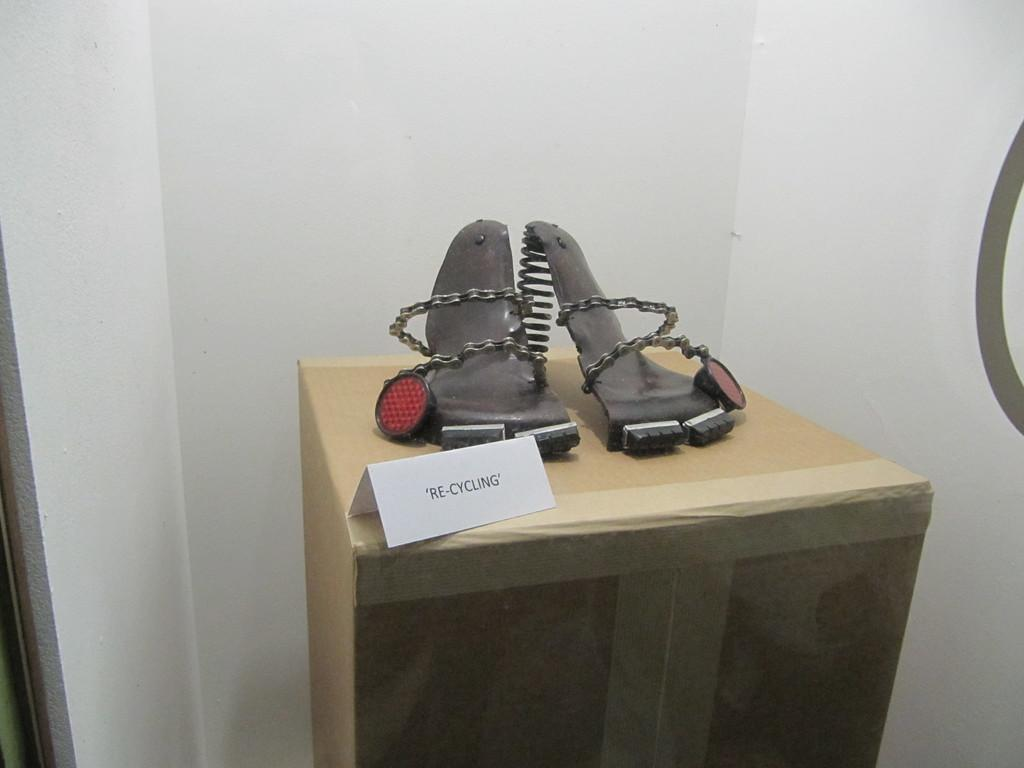What is the main subject of the image? There is a recycled object in the center of the image. How is the recycled object positioned in the image? The recycled object is placed on a cardboard box. What can be seen in the background of the image? There is a wall in the background of the image. What type of summer feeling is expressed by the recycled object in the image? There is no indication of a summer feeling or any emotions in the image, as it only features a recycled object on a cardboard box with a wall in the background. 